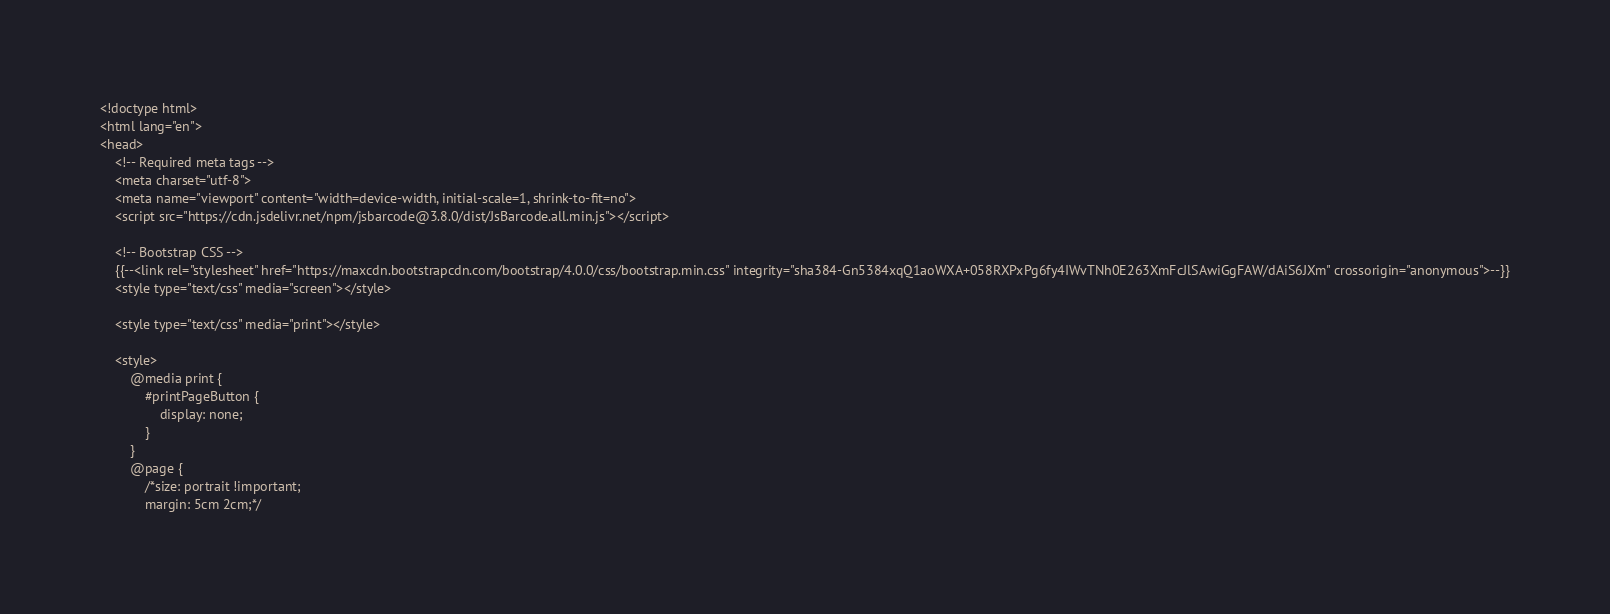<code> <loc_0><loc_0><loc_500><loc_500><_PHP_><!doctype html>
<html lang="en">
<head>
    <!-- Required meta tags -->
    <meta charset="utf-8">
    <meta name="viewport" content="width=device-width, initial-scale=1, shrink-to-fit=no">
    <script src="https://cdn.jsdelivr.net/npm/jsbarcode@3.8.0/dist/JsBarcode.all.min.js"></script>

    <!-- Bootstrap CSS -->
    {{--<link rel="stylesheet" href="https://maxcdn.bootstrapcdn.com/bootstrap/4.0.0/css/bootstrap.min.css" integrity="sha384-Gn5384xqQ1aoWXA+058RXPxPg6fy4IWvTNh0E263XmFcJlSAwiGgFAW/dAiS6JXm" crossorigin="anonymous">--}}
    <style type="text/css" media="screen"></style>

    <style type="text/css" media="print"></style>

    <style>
        @media print {
            #printPageButton {
                display: none;
            }
        }
        @page {
            /*size: portrait !important;
            margin: 5cm 2cm;*/</code> 